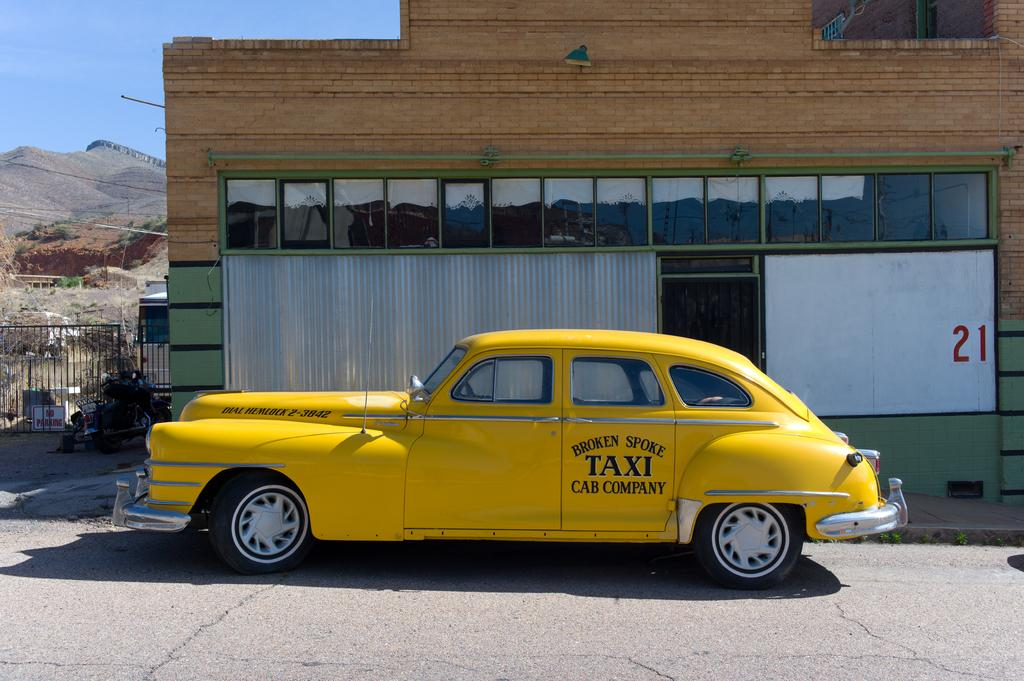<image>
Provide a brief description of the given image. an old yellow taxi cab is parked next to a building with the number 21 by a window. 